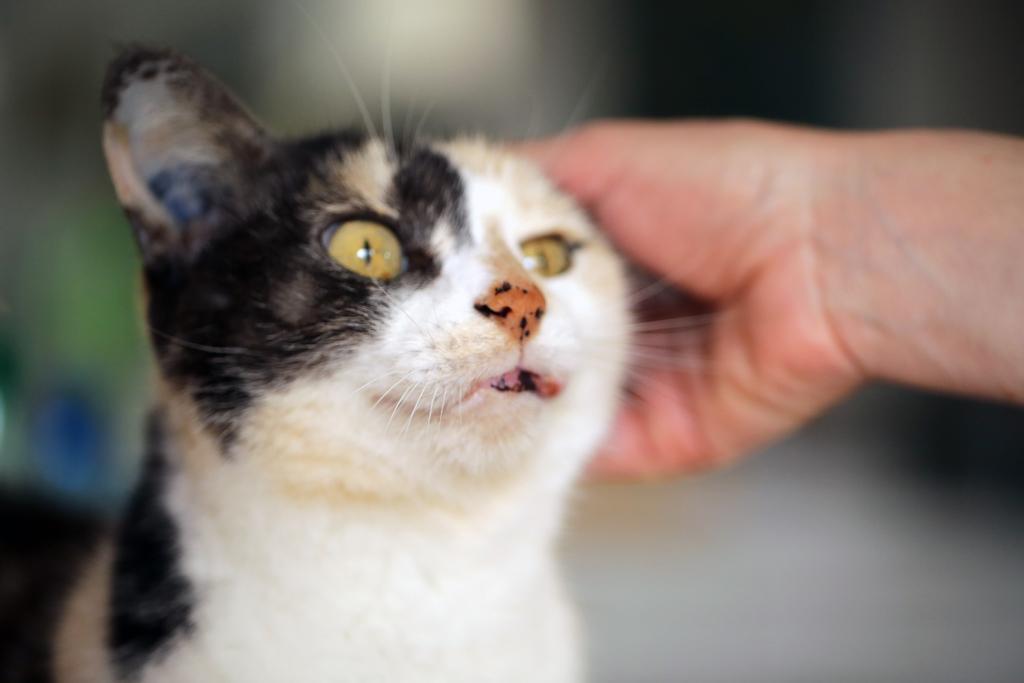Can you describe this image briefly? In this image, we can see a person hand. There is a cat in the middle of the image. In the background, image is blurred. 